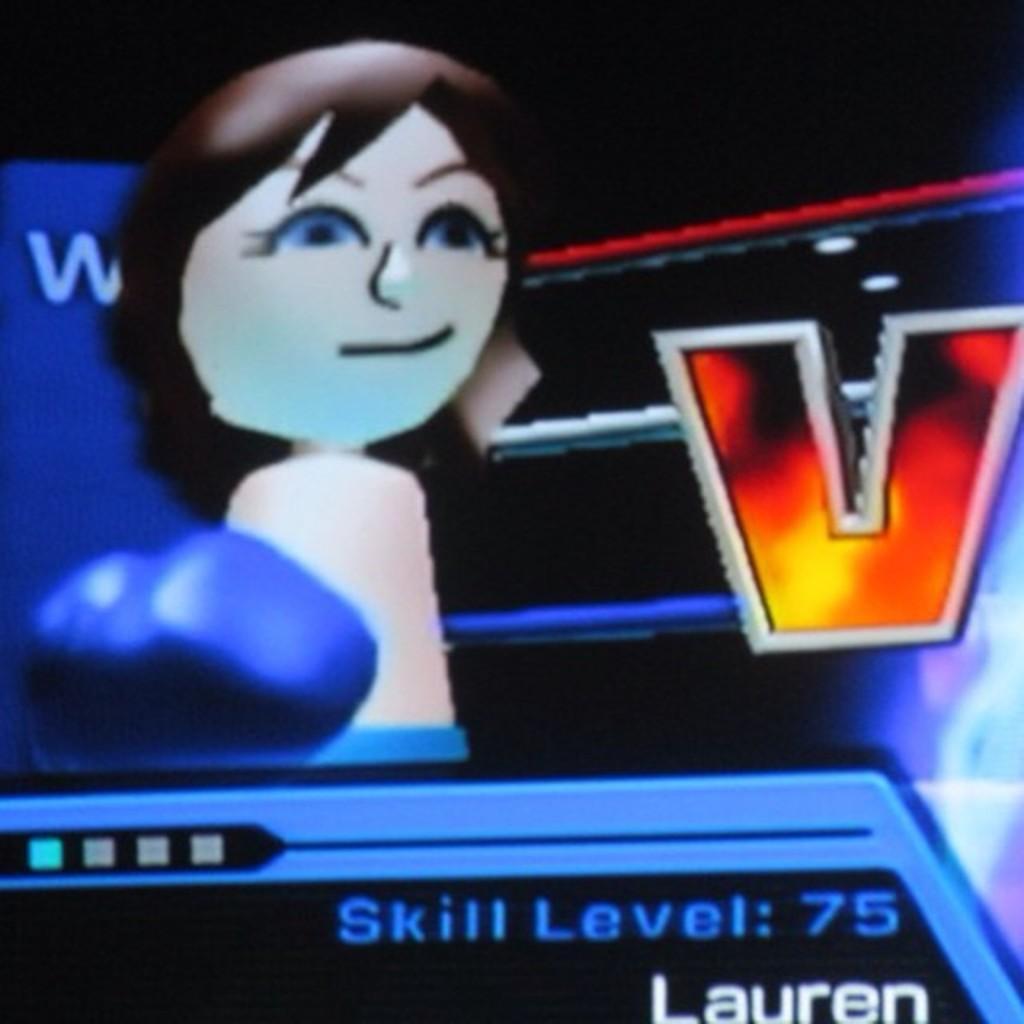In one or two sentences, can you explain what this image depicts? In this picture we can see a cartoon image of a girl, here we can see a glove, rods, some text and in the background we can see it is dark. 